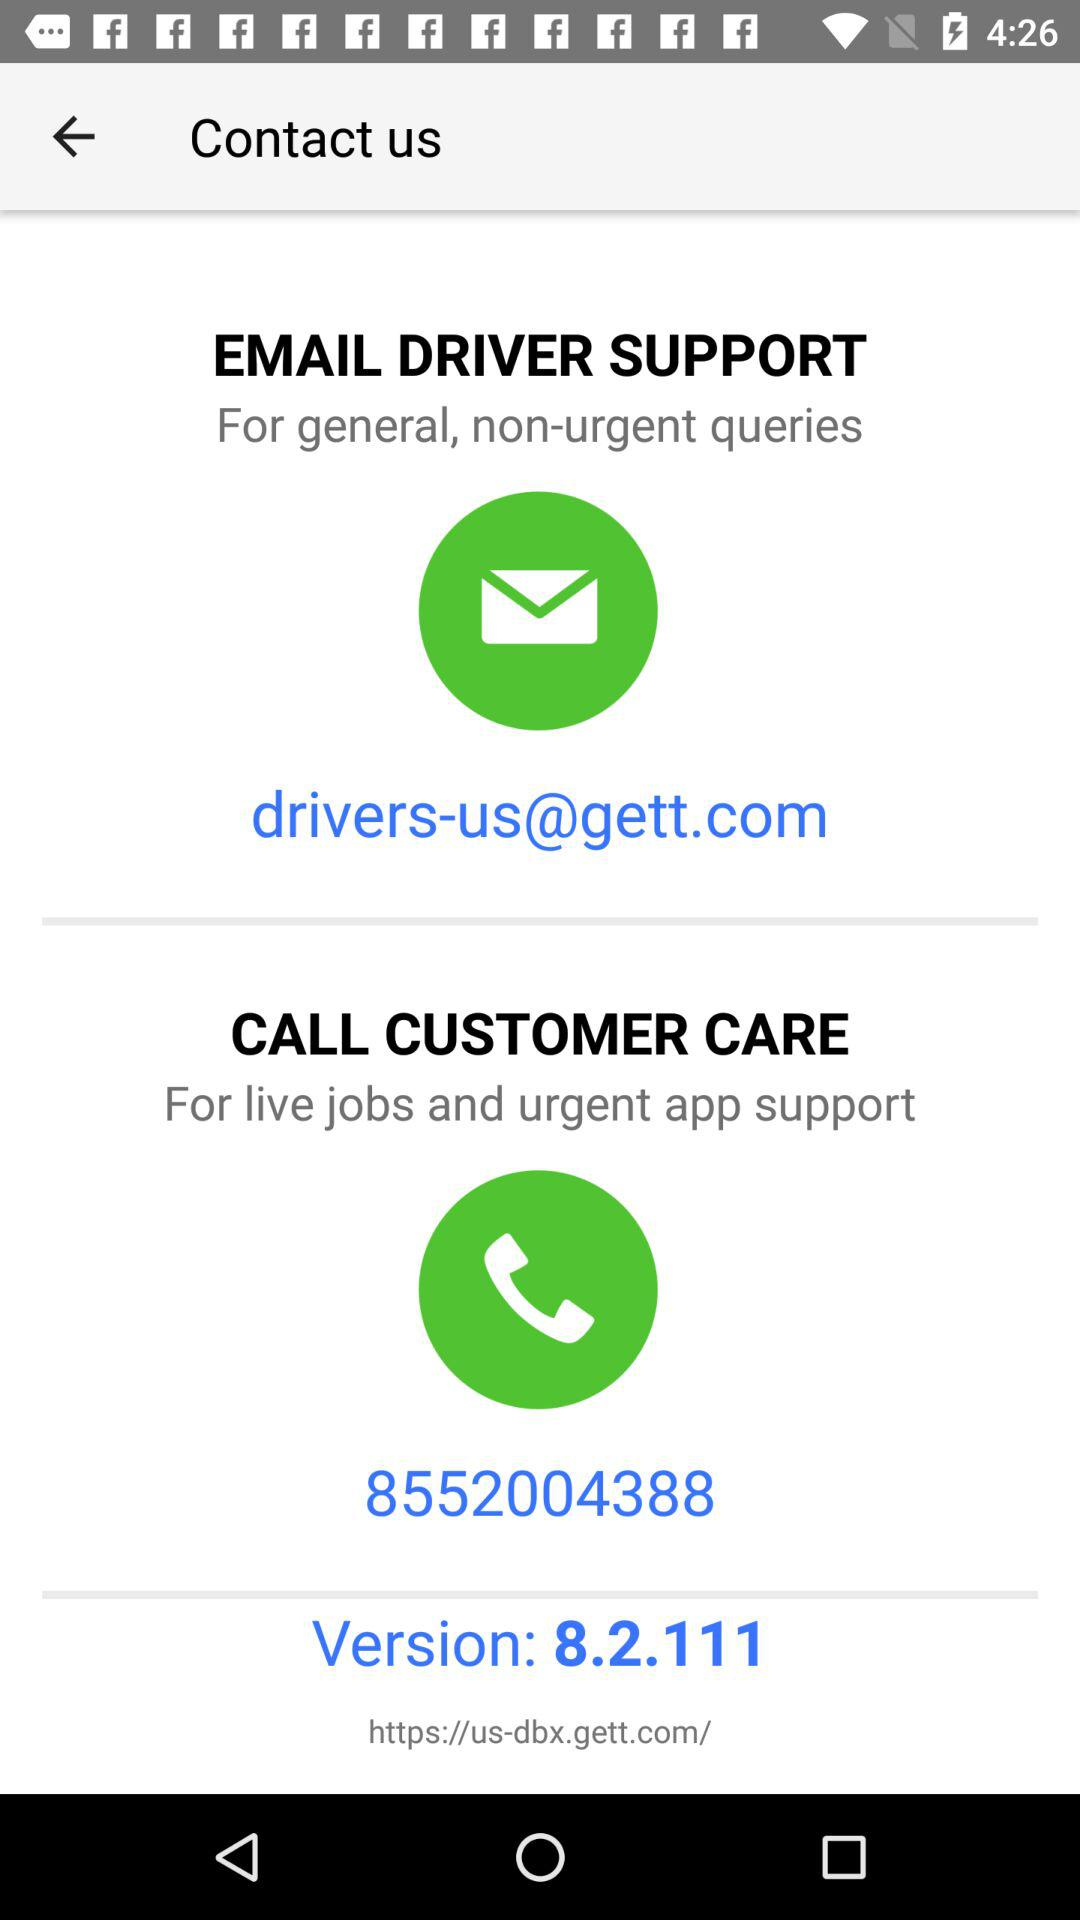How many contact options are there for non-urgent queries?
Answer the question using a single word or phrase. 1 